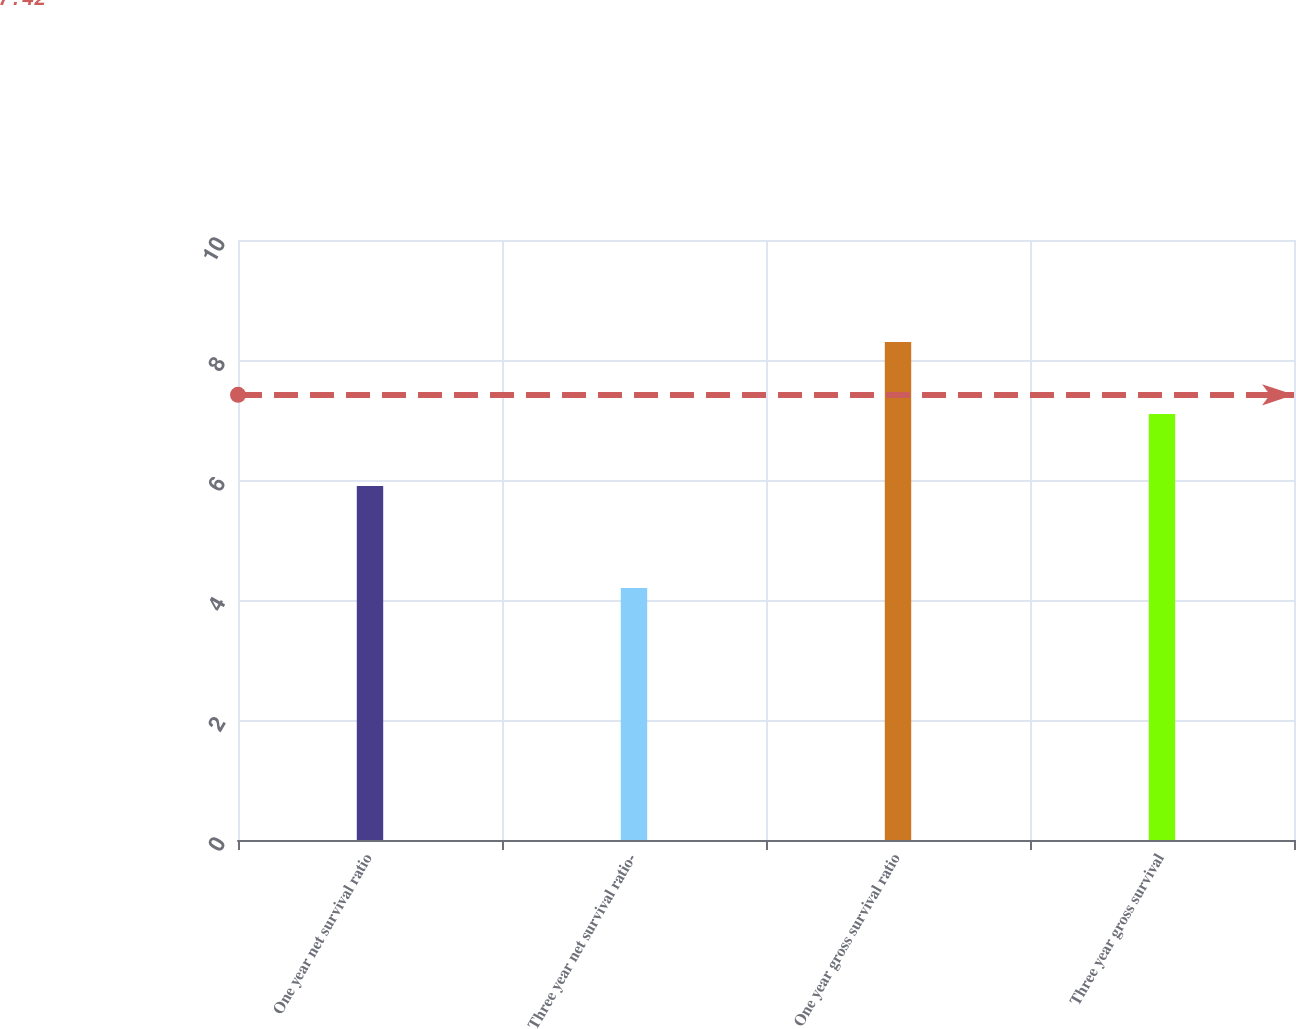<chart> <loc_0><loc_0><loc_500><loc_500><bar_chart><fcel>One year net survival ratio<fcel>Three year net survival ratio-<fcel>One year gross survival ratio<fcel>Three year gross survival<nl><fcel>5.9<fcel>4.2<fcel>8.3<fcel>7.1<nl></chart> 